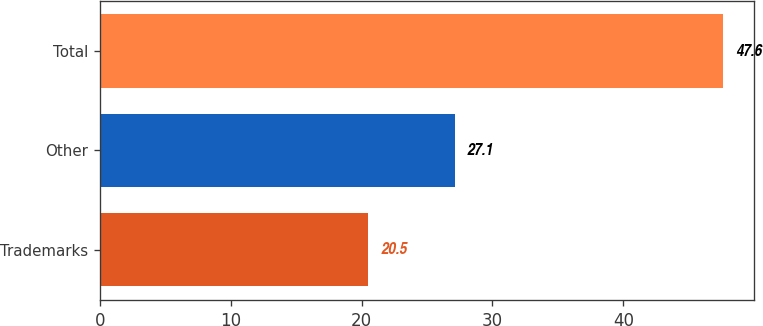Convert chart. <chart><loc_0><loc_0><loc_500><loc_500><bar_chart><fcel>Trademarks<fcel>Other<fcel>Total<nl><fcel>20.5<fcel>27.1<fcel>47.6<nl></chart> 